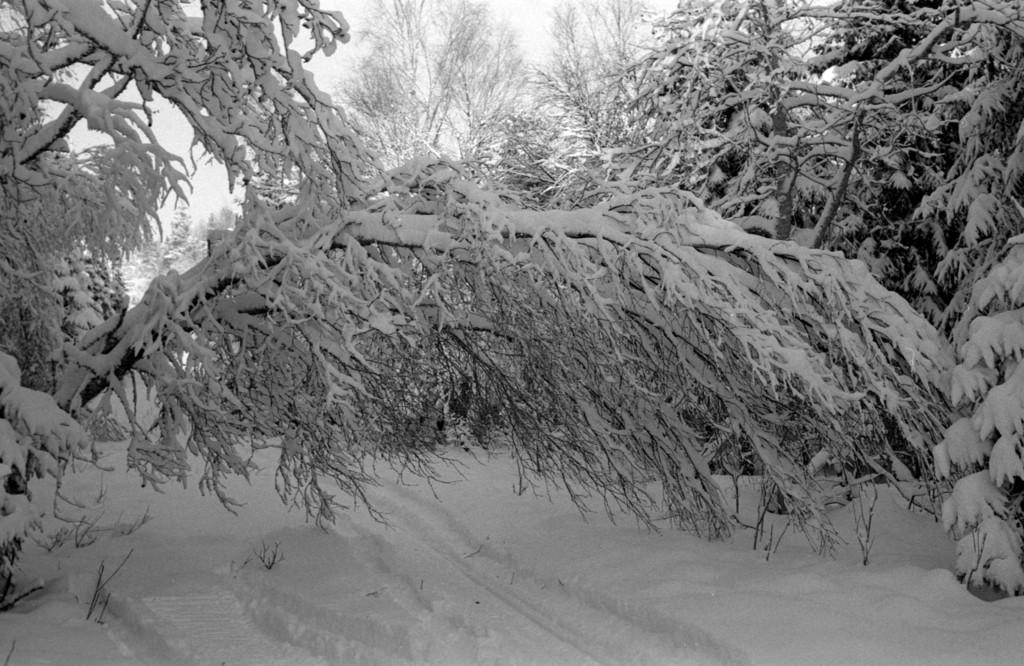What is covering the trees in the image? There is snow on the trees in the image. What is covering the ground in the image? There is snow on the ground in the image. What is the condition of the sky in the image? The sky appears to be cloudy in the image. What is the name of the authority figure in the image? There is no authority figure present in the image. Can you see a plane flying in the image? There is no plane visible in the image. 